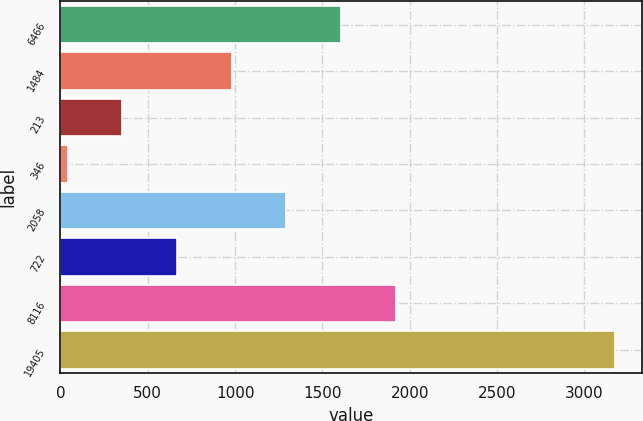Convert chart to OTSL. <chart><loc_0><loc_0><loc_500><loc_500><bar_chart><fcel>6466<fcel>1484<fcel>213<fcel>346<fcel>2058<fcel>722<fcel>8116<fcel>19405<nl><fcel>1607.6<fcel>981.24<fcel>354.88<fcel>41.7<fcel>1294.42<fcel>668.06<fcel>1920.78<fcel>3173.5<nl></chart> 